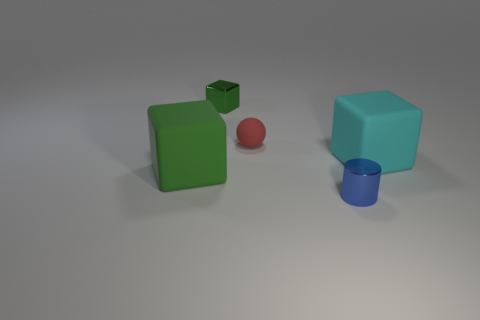There is a green object on the right side of the large green thing; how big is it?
Give a very brief answer. Small. Is the number of big cyan rubber cubes that are to the left of the blue object less than the number of tiny blue cylinders?
Ensure brevity in your answer.  Yes. Is the shiny cube the same color as the tiny sphere?
Make the answer very short. No. Are there any other things that have the same shape as the big cyan matte object?
Offer a very short reply. Yes. Are there fewer tiny brown shiny objects than blue cylinders?
Offer a terse response. Yes. There is a matte thing right of the tiny metal thing that is to the right of the small matte sphere; what color is it?
Your answer should be very brief. Cyan. What material is the big object to the right of the big green cube that is in front of the tiny matte ball that is to the left of the tiny blue cylinder made of?
Keep it short and to the point. Rubber. There is a block right of the sphere; does it have the same size as the metal block?
Your response must be concise. No. There is a small red object that is to the right of the metal cube; what is it made of?
Your answer should be compact. Rubber. Is the number of small red metal cylinders greater than the number of tiny objects?
Make the answer very short. No. 